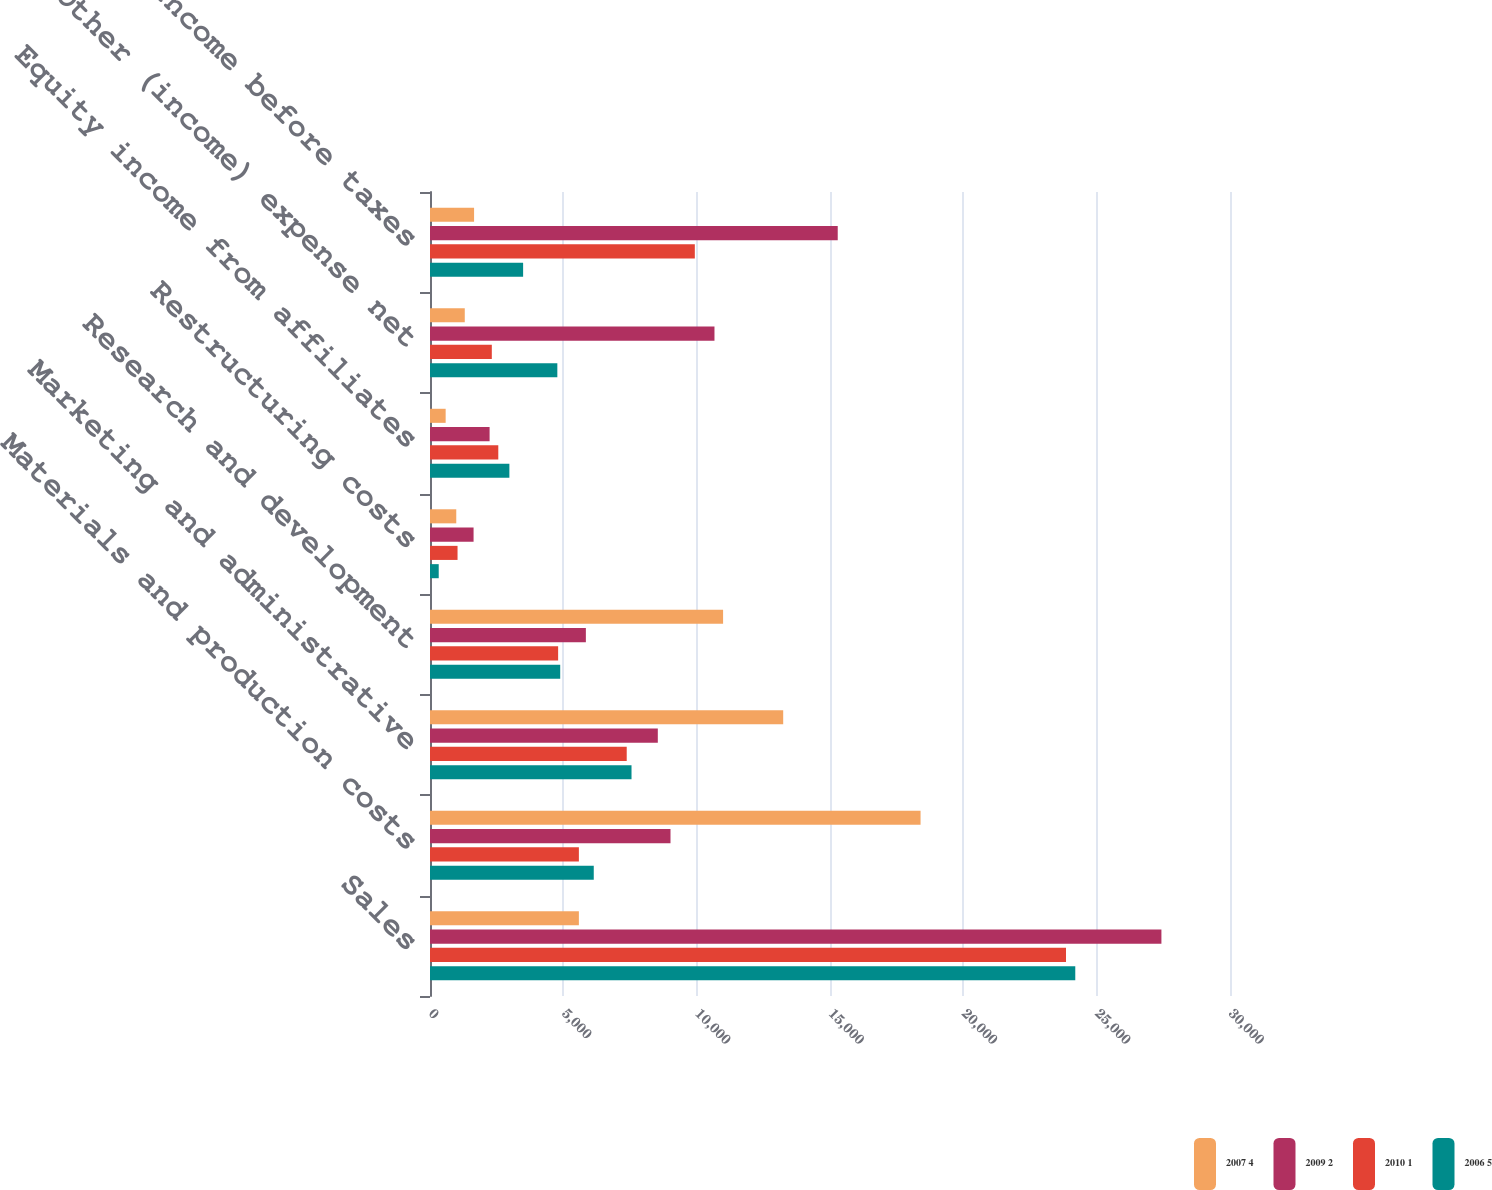Convert chart. <chart><loc_0><loc_0><loc_500><loc_500><stacked_bar_chart><ecel><fcel>Sales<fcel>Materials and production costs<fcel>Marketing and administrative<fcel>Research and development<fcel>Restructuring costs<fcel>Equity income from affiliates<fcel>Other (income) expense net<fcel>Income before taxes<nl><fcel>2007 4<fcel>5583<fcel>18396<fcel>13245<fcel>10991<fcel>985<fcel>587<fcel>1304<fcel>1653<nl><fcel>2009 2<fcel>27428<fcel>9019<fcel>8543<fcel>5845<fcel>1634<fcel>2235<fcel>10668<fcel>15290<nl><fcel>2010 1<fcel>23850<fcel>5583<fcel>7377<fcel>4805<fcel>1033<fcel>2561<fcel>2318<fcel>9931<nl><fcel>2006 5<fcel>24198<fcel>6141<fcel>7557<fcel>4883<fcel>327<fcel>2977<fcel>4775<fcel>3492<nl></chart> 